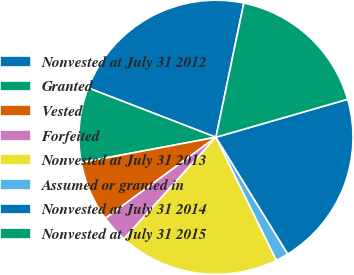Convert chart to OTSL. <chart><loc_0><loc_0><loc_500><loc_500><pie_chart><fcel>Nonvested at July 31 2012<fcel>Granted<fcel>Vested<fcel>Forfeited<fcel>Nonvested at July 31 2013<fcel>Assumed or granted in<fcel>Nonvested at July 31 2014<fcel>Nonvested at July 31 2015<nl><fcel>22.4%<fcel>8.82%<fcel>7.11%<fcel>3.22%<fcel>18.98%<fcel>1.51%<fcel>20.69%<fcel>17.27%<nl></chart> 